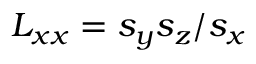Convert formula to latex. <formula><loc_0><loc_0><loc_500><loc_500>L _ { x x } = s _ { y } s _ { z } / s _ { x }</formula> 